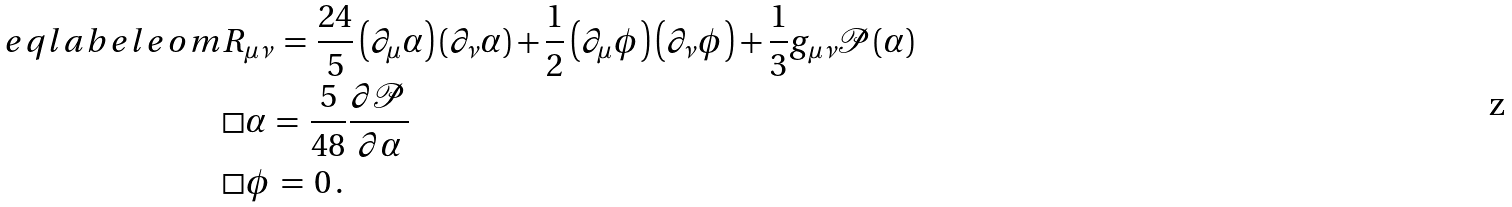<formula> <loc_0><loc_0><loc_500><loc_500>\ e q l a b e l { e o m } & R _ { \mu \nu } \, = \, \frac { 2 4 } { 5 } \left ( \partial _ { \mu } \alpha \right ) \left ( \partial _ { \nu } \alpha \right ) + \frac { 1 } { 2 } \left ( \partial _ { \mu } \phi \right ) \left ( \partial _ { \nu } \phi \right ) + \frac { 1 } { 3 } g _ { \mu \nu } \mathcal { P } ( \alpha ) \\ & \Box \alpha \, = \, \frac { 5 } { 4 8 } \frac { \partial \mathcal { P } } { \partial \alpha } \\ & \Box \phi \, = \, 0 \, .</formula> 